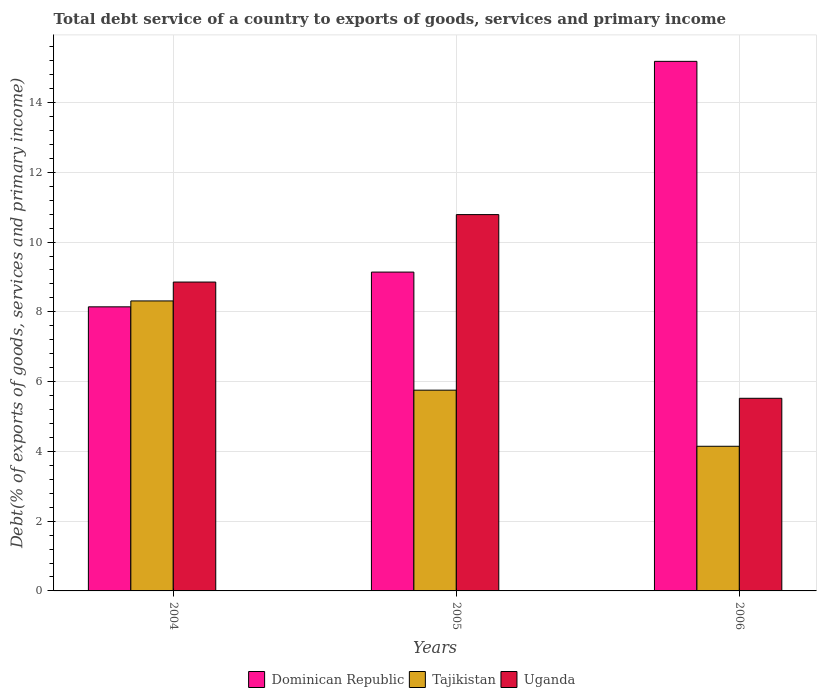How many different coloured bars are there?
Your response must be concise. 3. How many bars are there on the 1st tick from the left?
Your response must be concise. 3. How many bars are there on the 2nd tick from the right?
Your answer should be compact. 3. What is the label of the 1st group of bars from the left?
Offer a very short reply. 2004. What is the total debt service in Uganda in 2004?
Give a very brief answer. 8.85. Across all years, what is the maximum total debt service in Dominican Republic?
Give a very brief answer. 15.18. Across all years, what is the minimum total debt service in Tajikistan?
Your answer should be very brief. 4.15. What is the total total debt service in Dominican Republic in the graph?
Your response must be concise. 32.46. What is the difference between the total debt service in Dominican Republic in 2004 and that in 2005?
Your answer should be very brief. -1. What is the difference between the total debt service in Uganda in 2005 and the total debt service in Dominican Republic in 2004?
Provide a succinct answer. 2.64. What is the average total debt service in Uganda per year?
Provide a succinct answer. 8.39. In the year 2004, what is the difference between the total debt service in Dominican Republic and total debt service in Tajikistan?
Make the answer very short. -0.17. What is the ratio of the total debt service in Dominican Republic in 2004 to that in 2005?
Keep it short and to the point. 0.89. Is the total debt service in Uganda in 2004 less than that in 2006?
Give a very brief answer. No. Is the difference between the total debt service in Dominican Republic in 2004 and 2006 greater than the difference between the total debt service in Tajikistan in 2004 and 2006?
Ensure brevity in your answer.  No. What is the difference between the highest and the second highest total debt service in Dominican Republic?
Make the answer very short. 6.04. What is the difference between the highest and the lowest total debt service in Tajikistan?
Provide a short and direct response. 4.17. What does the 1st bar from the left in 2005 represents?
Provide a short and direct response. Dominican Republic. What does the 3rd bar from the right in 2006 represents?
Offer a very short reply. Dominican Republic. How many years are there in the graph?
Keep it short and to the point. 3. What is the difference between two consecutive major ticks on the Y-axis?
Ensure brevity in your answer.  2. Does the graph contain any zero values?
Ensure brevity in your answer.  No. Does the graph contain grids?
Provide a succinct answer. Yes. How are the legend labels stacked?
Make the answer very short. Horizontal. What is the title of the graph?
Give a very brief answer. Total debt service of a country to exports of goods, services and primary income. What is the label or title of the X-axis?
Offer a very short reply. Years. What is the label or title of the Y-axis?
Your answer should be compact. Debt(% of exports of goods, services and primary income). What is the Debt(% of exports of goods, services and primary income) in Dominican Republic in 2004?
Keep it short and to the point. 8.14. What is the Debt(% of exports of goods, services and primary income) in Tajikistan in 2004?
Your answer should be compact. 8.31. What is the Debt(% of exports of goods, services and primary income) in Uganda in 2004?
Your answer should be very brief. 8.85. What is the Debt(% of exports of goods, services and primary income) of Dominican Republic in 2005?
Offer a terse response. 9.14. What is the Debt(% of exports of goods, services and primary income) in Tajikistan in 2005?
Offer a terse response. 5.75. What is the Debt(% of exports of goods, services and primary income) of Uganda in 2005?
Your response must be concise. 10.79. What is the Debt(% of exports of goods, services and primary income) in Dominican Republic in 2006?
Offer a very short reply. 15.18. What is the Debt(% of exports of goods, services and primary income) in Tajikistan in 2006?
Provide a succinct answer. 4.15. What is the Debt(% of exports of goods, services and primary income) in Uganda in 2006?
Your answer should be very brief. 5.52. Across all years, what is the maximum Debt(% of exports of goods, services and primary income) in Dominican Republic?
Give a very brief answer. 15.18. Across all years, what is the maximum Debt(% of exports of goods, services and primary income) of Tajikistan?
Provide a succinct answer. 8.31. Across all years, what is the maximum Debt(% of exports of goods, services and primary income) in Uganda?
Your answer should be very brief. 10.79. Across all years, what is the minimum Debt(% of exports of goods, services and primary income) in Dominican Republic?
Your response must be concise. 8.14. Across all years, what is the minimum Debt(% of exports of goods, services and primary income) of Tajikistan?
Your answer should be compact. 4.15. Across all years, what is the minimum Debt(% of exports of goods, services and primary income) in Uganda?
Your answer should be very brief. 5.52. What is the total Debt(% of exports of goods, services and primary income) in Dominican Republic in the graph?
Provide a succinct answer. 32.46. What is the total Debt(% of exports of goods, services and primary income) in Tajikistan in the graph?
Ensure brevity in your answer.  18.21. What is the total Debt(% of exports of goods, services and primary income) in Uganda in the graph?
Keep it short and to the point. 25.16. What is the difference between the Debt(% of exports of goods, services and primary income) of Dominican Republic in 2004 and that in 2005?
Offer a terse response. -1. What is the difference between the Debt(% of exports of goods, services and primary income) in Tajikistan in 2004 and that in 2005?
Make the answer very short. 2.56. What is the difference between the Debt(% of exports of goods, services and primary income) of Uganda in 2004 and that in 2005?
Your response must be concise. -1.93. What is the difference between the Debt(% of exports of goods, services and primary income) of Dominican Republic in 2004 and that in 2006?
Your answer should be very brief. -7.04. What is the difference between the Debt(% of exports of goods, services and primary income) in Tajikistan in 2004 and that in 2006?
Provide a succinct answer. 4.17. What is the difference between the Debt(% of exports of goods, services and primary income) of Uganda in 2004 and that in 2006?
Your response must be concise. 3.33. What is the difference between the Debt(% of exports of goods, services and primary income) in Dominican Republic in 2005 and that in 2006?
Ensure brevity in your answer.  -6.04. What is the difference between the Debt(% of exports of goods, services and primary income) in Tajikistan in 2005 and that in 2006?
Provide a succinct answer. 1.61. What is the difference between the Debt(% of exports of goods, services and primary income) in Uganda in 2005 and that in 2006?
Offer a very short reply. 5.27. What is the difference between the Debt(% of exports of goods, services and primary income) of Dominican Republic in 2004 and the Debt(% of exports of goods, services and primary income) of Tajikistan in 2005?
Ensure brevity in your answer.  2.39. What is the difference between the Debt(% of exports of goods, services and primary income) of Dominican Republic in 2004 and the Debt(% of exports of goods, services and primary income) of Uganda in 2005?
Provide a short and direct response. -2.64. What is the difference between the Debt(% of exports of goods, services and primary income) of Tajikistan in 2004 and the Debt(% of exports of goods, services and primary income) of Uganda in 2005?
Your answer should be compact. -2.48. What is the difference between the Debt(% of exports of goods, services and primary income) in Dominican Republic in 2004 and the Debt(% of exports of goods, services and primary income) in Tajikistan in 2006?
Offer a very short reply. 4. What is the difference between the Debt(% of exports of goods, services and primary income) of Dominican Republic in 2004 and the Debt(% of exports of goods, services and primary income) of Uganda in 2006?
Make the answer very short. 2.62. What is the difference between the Debt(% of exports of goods, services and primary income) of Tajikistan in 2004 and the Debt(% of exports of goods, services and primary income) of Uganda in 2006?
Keep it short and to the point. 2.79. What is the difference between the Debt(% of exports of goods, services and primary income) of Dominican Republic in 2005 and the Debt(% of exports of goods, services and primary income) of Tajikistan in 2006?
Your answer should be very brief. 4.99. What is the difference between the Debt(% of exports of goods, services and primary income) in Dominican Republic in 2005 and the Debt(% of exports of goods, services and primary income) in Uganda in 2006?
Make the answer very short. 3.62. What is the difference between the Debt(% of exports of goods, services and primary income) of Tajikistan in 2005 and the Debt(% of exports of goods, services and primary income) of Uganda in 2006?
Offer a terse response. 0.23. What is the average Debt(% of exports of goods, services and primary income) in Dominican Republic per year?
Your answer should be compact. 10.82. What is the average Debt(% of exports of goods, services and primary income) of Tajikistan per year?
Ensure brevity in your answer.  6.07. What is the average Debt(% of exports of goods, services and primary income) of Uganda per year?
Your response must be concise. 8.39. In the year 2004, what is the difference between the Debt(% of exports of goods, services and primary income) in Dominican Republic and Debt(% of exports of goods, services and primary income) in Tajikistan?
Keep it short and to the point. -0.17. In the year 2004, what is the difference between the Debt(% of exports of goods, services and primary income) in Dominican Republic and Debt(% of exports of goods, services and primary income) in Uganda?
Your answer should be very brief. -0.71. In the year 2004, what is the difference between the Debt(% of exports of goods, services and primary income) of Tajikistan and Debt(% of exports of goods, services and primary income) of Uganda?
Ensure brevity in your answer.  -0.54. In the year 2005, what is the difference between the Debt(% of exports of goods, services and primary income) in Dominican Republic and Debt(% of exports of goods, services and primary income) in Tajikistan?
Offer a terse response. 3.38. In the year 2005, what is the difference between the Debt(% of exports of goods, services and primary income) of Dominican Republic and Debt(% of exports of goods, services and primary income) of Uganda?
Provide a short and direct response. -1.65. In the year 2005, what is the difference between the Debt(% of exports of goods, services and primary income) in Tajikistan and Debt(% of exports of goods, services and primary income) in Uganda?
Provide a short and direct response. -5.03. In the year 2006, what is the difference between the Debt(% of exports of goods, services and primary income) in Dominican Republic and Debt(% of exports of goods, services and primary income) in Tajikistan?
Make the answer very short. 11.03. In the year 2006, what is the difference between the Debt(% of exports of goods, services and primary income) of Dominican Republic and Debt(% of exports of goods, services and primary income) of Uganda?
Your answer should be compact. 9.66. In the year 2006, what is the difference between the Debt(% of exports of goods, services and primary income) in Tajikistan and Debt(% of exports of goods, services and primary income) in Uganda?
Give a very brief answer. -1.38. What is the ratio of the Debt(% of exports of goods, services and primary income) in Dominican Republic in 2004 to that in 2005?
Your answer should be compact. 0.89. What is the ratio of the Debt(% of exports of goods, services and primary income) of Tajikistan in 2004 to that in 2005?
Your response must be concise. 1.44. What is the ratio of the Debt(% of exports of goods, services and primary income) of Uganda in 2004 to that in 2005?
Your answer should be very brief. 0.82. What is the ratio of the Debt(% of exports of goods, services and primary income) in Dominican Republic in 2004 to that in 2006?
Offer a very short reply. 0.54. What is the ratio of the Debt(% of exports of goods, services and primary income) of Tajikistan in 2004 to that in 2006?
Provide a short and direct response. 2. What is the ratio of the Debt(% of exports of goods, services and primary income) of Uganda in 2004 to that in 2006?
Keep it short and to the point. 1.6. What is the ratio of the Debt(% of exports of goods, services and primary income) in Dominican Republic in 2005 to that in 2006?
Provide a succinct answer. 0.6. What is the ratio of the Debt(% of exports of goods, services and primary income) of Tajikistan in 2005 to that in 2006?
Your answer should be compact. 1.39. What is the ratio of the Debt(% of exports of goods, services and primary income) of Uganda in 2005 to that in 2006?
Provide a succinct answer. 1.95. What is the difference between the highest and the second highest Debt(% of exports of goods, services and primary income) of Dominican Republic?
Ensure brevity in your answer.  6.04. What is the difference between the highest and the second highest Debt(% of exports of goods, services and primary income) of Tajikistan?
Provide a short and direct response. 2.56. What is the difference between the highest and the second highest Debt(% of exports of goods, services and primary income) in Uganda?
Provide a short and direct response. 1.93. What is the difference between the highest and the lowest Debt(% of exports of goods, services and primary income) of Dominican Republic?
Give a very brief answer. 7.04. What is the difference between the highest and the lowest Debt(% of exports of goods, services and primary income) of Tajikistan?
Keep it short and to the point. 4.17. What is the difference between the highest and the lowest Debt(% of exports of goods, services and primary income) in Uganda?
Offer a terse response. 5.27. 